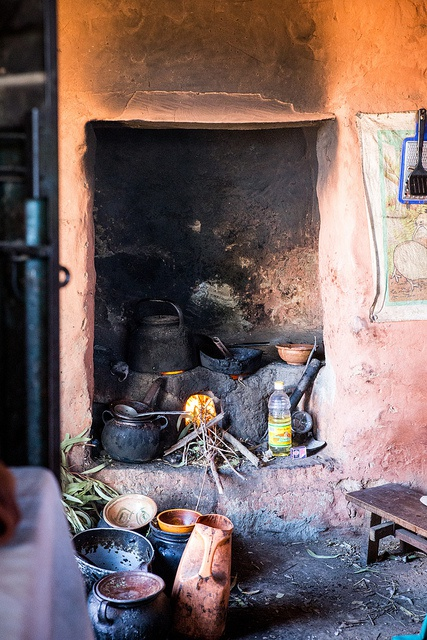Describe the objects in this image and their specific colors. I can see bench in black, gray, and darkgray tones, bowl in black, lightgray, darkgray, brown, and pink tones, bottle in black, white, khaki, and darkgray tones, bowl in black, maroon, lavender, and orange tones, and bowl in black, tan, brown, salmon, and lightgray tones in this image. 